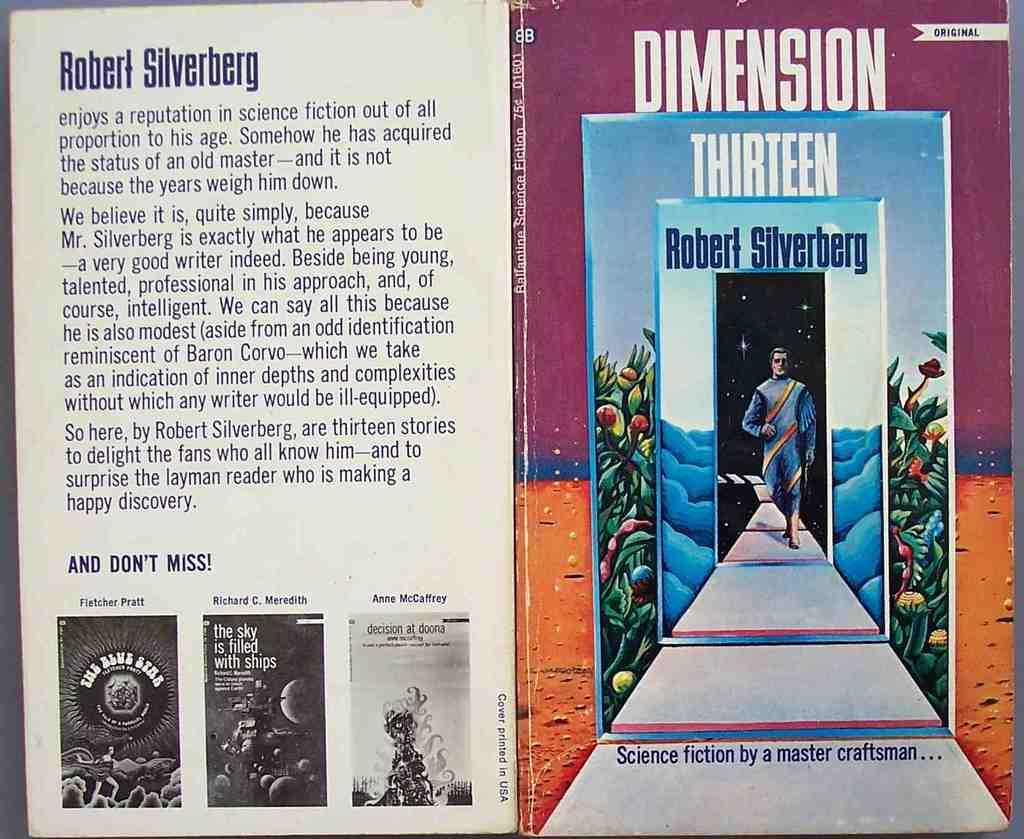<image>
Render a clear and concise summary of the photo. A red and blue book that is called Dimension Thirteen 